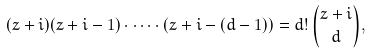Convert formula to latex. <formula><loc_0><loc_0><loc_500><loc_500>( z + i ) ( z + i - 1 ) \cdot \dots \cdot ( z + i - ( d - 1 ) ) = d ! \, \binom { z + i } { d } ,</formula> 